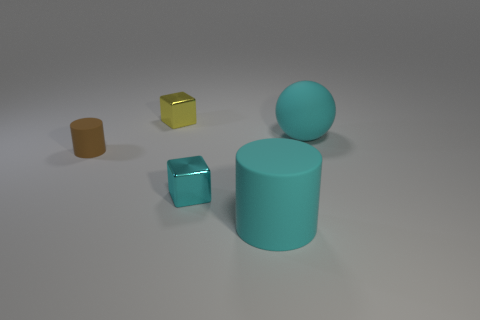What shape is the object on the right side of the big cylinder?
Ensure brevity in your answer.  Sphere. There is a cyan sphere; is its size the same as the block that is behind the small cyan object?
Offer a terse response. No. Are there any large red cylinders that have the same material as the small yellow cube?
Your response must be concise. No. What number of cylinders are large cyan objects or brown matte objects?
Give a very brief answer. 2. Is there a tiny object that is in front of the shiny cube that is in front of the large cyan rubber sphere?
Provide a short and direct response. No. Is the number of tiny yellow things less than the number of large green spheres?
Make the answer very short. No. What number of other things are the same shape as the tiny yellow thing?
Your response must be concise. 1. How many brown things are either metallic objects or big objects?
Your response must be concise. 0. There is a cyan rubber object behind the large matte cylinder in front of the brown object; how big is it?
Ensure brevity in your answer.  Large. What is the material of the other big thing that is the same shape as the brown rubber object?
Give a very brief answer. Rubber. 